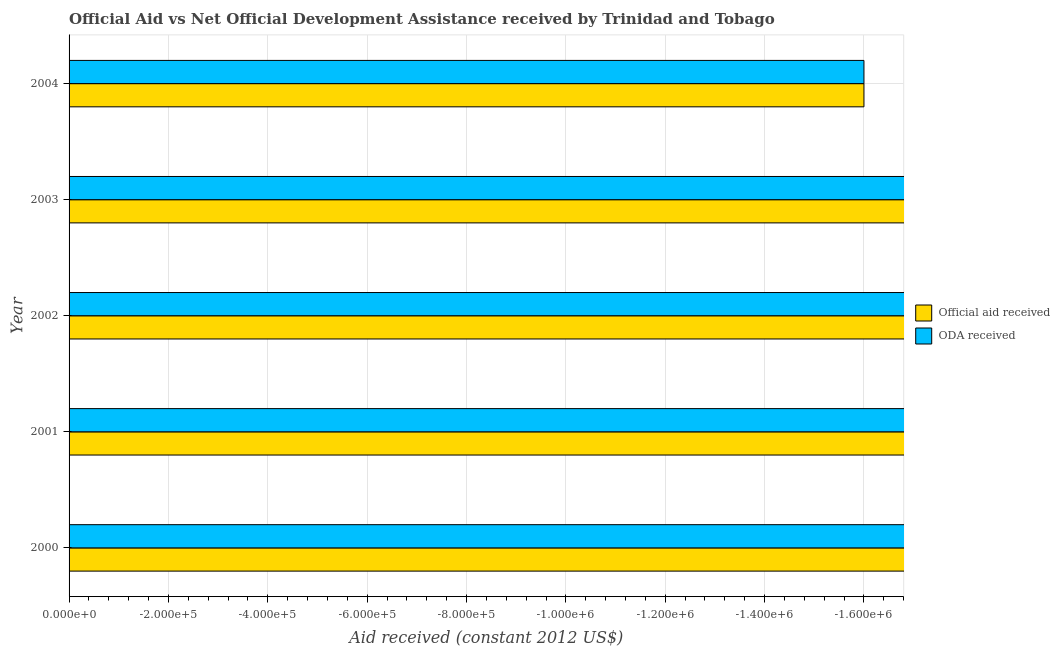How many different coloured bars are there?
Your response must be concise. 0. Are the number of bars on each tick of the Y-axis equal?
Offer a very short reply. Yes. How many bars are there on the 5th tick from the top?
Provide a short and direct response. 0. What is the label of the 5th group of bars from the top?
Ensure brevity in your answer.  2000. What is the official aid received in 2001?
Your response must be concise. 0. Across all years, what is the minimum official aid received?
Offer a very short reply. 0. What is the difference between the official aid received in 2001 and the oda received in 2003?
Offer a very short reply. 0. What is the average official aid received per year?
Offer a very short reply. 0. How many years are there in the graph?
Offer a very short reply. 5. What is the difference between two consecutive major ticks on the X-axis?
Your answer should be very brief. 2.00e+05. Where does the legend appear in the graph?
Your response must be concise. Center right. How are the legend labels stacked?
Your answer should be very brief. Vertical. What is the title of the graph?
Your answer should be very brief. Official Aid vs Net Official Development Assistance received by Trinidad and Tobago . Does "Foreign liabilities" appear as one of the legend labels in the graph?
Ensure brevity in your answer.  No. What is the label or title of the X-axis?
Give a very brief answer. Aid received (constant 2012 US$). What is the Aid received (constant 2012 US$) in ODA received in 2000?
Provide a succinct answer. 0. What is the Aid received (constant 2012 US$) in Official aid received in 2001?
Your response must be concise. 0. What is the Aid received (constant 2012 US$) in Official aid received in 2002?
Ensure brevity in your answer.  0. What is the Aid received (constant 2012 US$) of ODA received in 2002?
Ensure brevity in your answer.  0. What is the Aid received (constant 2012 US$) of ODA received in 2003?
Your response must be concise. 0. What is the total Aid received (constant 2012 US$) of Official aid received in the graph?
Give a very brief answer. 0. What is the average Aid received (constant 2012 US$) in Official aid received per year?
Make the answer very short. 0. What is the average Aid received (constant 2012 US$) of ODA received per year?
Ensure brevity in your answer.  0. 